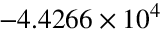<formula> <loc_0><loc_0><loc_500><loc_500>- 4 . 4 2 6 6 \times 1 0 ^ { 4 }</formula> 